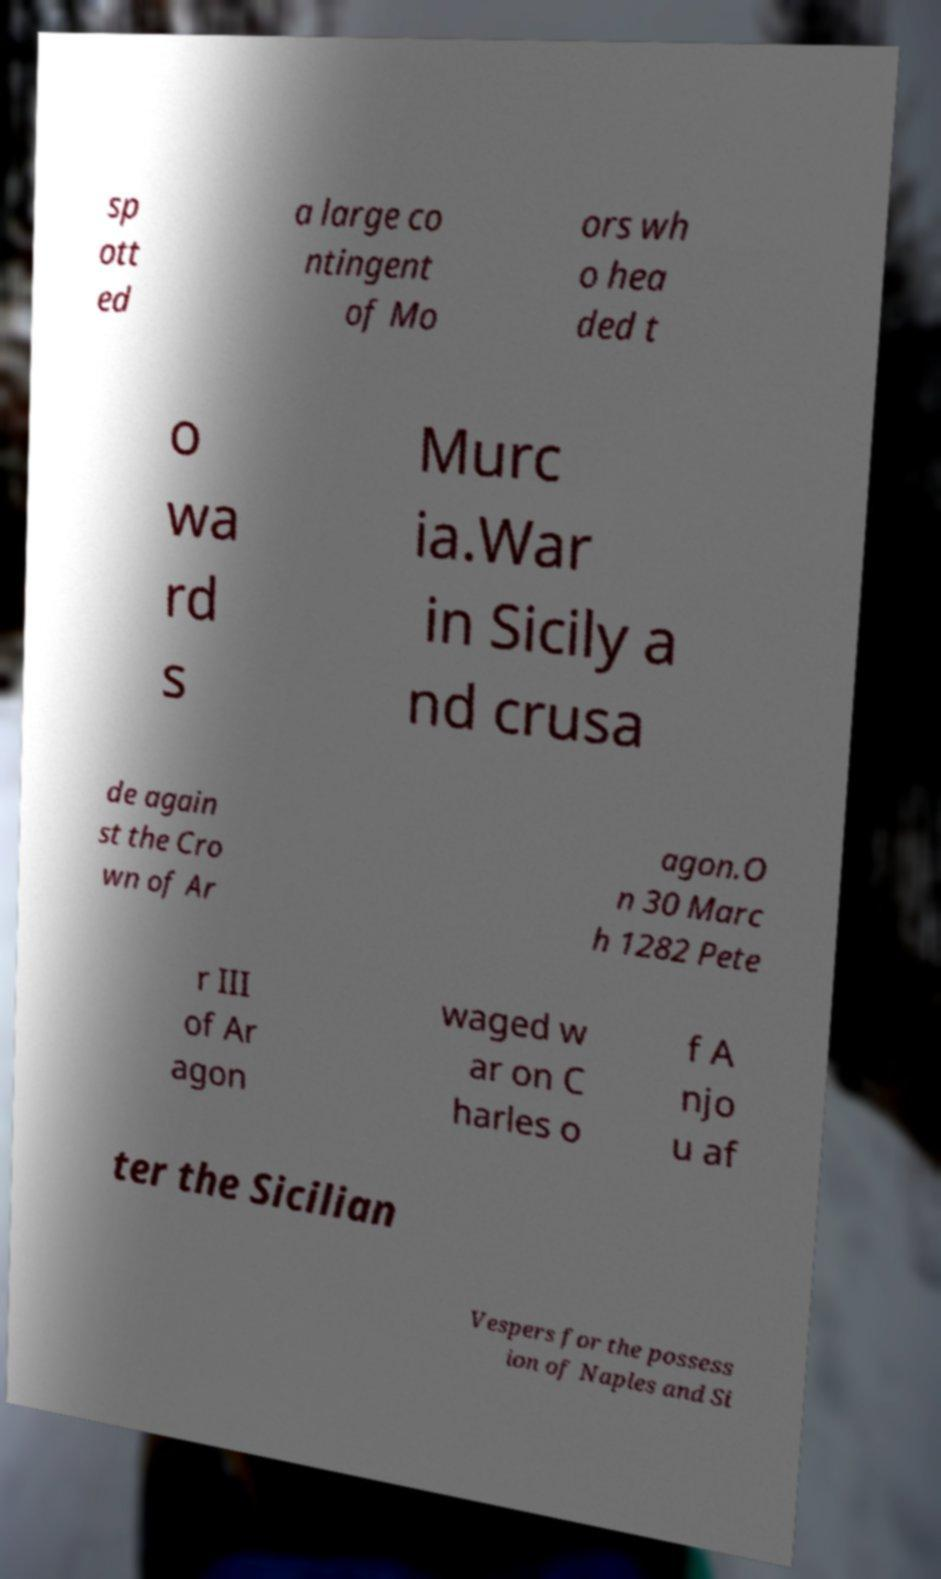I need the written content from this picture converted into text. Can you do that? sp ott ed a large co ntingent of Mo ors wh o hea ded t o wa rd s Murc ia.War in Sicily a nd crusa de again st the Cro wn of Ar agon.O n 30 Marc h 1282 Pete r III of Ar agon waged w ar on C harles o f A njo u af ter the Sicilian Vespers for the possess ion of Naples and Si 